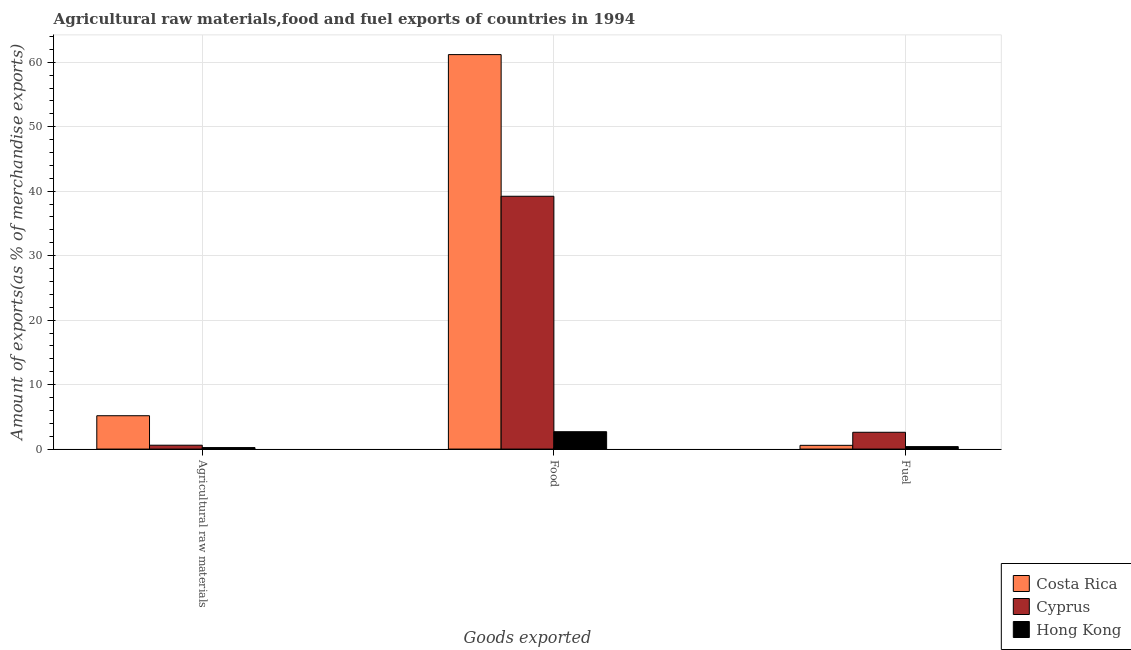How many different coloured bars are there?
Provide a succinct answer. 3. How many groups of bars are there?
Give a very brief answer. 3. What is the label of the 3rd group of bars from the left?
Your response must be concise. Fuel. What is the percentage of fuel exports in Cyprus?
Your answer should be very brief. 2.61. Across all countries, what is the maximum percentage of food exports?
Your answer should be very brief. 61.19. Across all countries, what is the minimum percentage of fuel exports?
Provide a short and direct response. 0.38. In which country was the percentage of food exports maximum?
Ensure brevity in your answer.  Costa Rica. In which country was the percentage of raw materials exports minimum?
Your answer should be very brief. Hong Kong. What is the total percentage of raw materials exports in the graph?
Keep it short and to the point. 6. What is the difference between the percentage of raw materials exports in Hong Kong and that in Cyprus?
Make the answer very short. -0.37. What is the difference between the percentage of raw materials exports in Costa Rica and the percentage of food exports in Hong Kong?
Make the answer very short. 2.48. What is the average percentage of fuel exports per country?
Your answer should be compact. 1.19. What is the difference between the percentage of raw materials exports and percentage of food exports in Hong Kong?
Give a very brief answer. -2.46. In how many countries, is the percentage of fuel exports greater than 40 %?
Provide a succinct answer. 0. What is the ratio of the percentage of raw materials exports in Cyprus to that in Hong Kong?
Your answer should be very brief. 2.57. What is the difference between the highest and the second highest percentage of food exports?
Your answer should be very brief. 21.97. What is the difference between the highest and the lowest percentage of food exports?
Your response must be concise. 58.49. Is the sum of the percentage of fuel exports in Cyprus and Costa Rica greater than the maximum percentage of raw materials exports across all countries?
Offer a terse response. No. What does the 3rd bar from the left in Agricultural raw materials represents?
Keep it short and to the point. Hong Kong. What does the 2nd bar from the right in Agricultural raw materials represents?
Your answer should be very brief. Cyprus. Is it the case that in every country, the sum of the percentage of raw materials exports and percentage of food exports is greater than the percentage of fuel exports?
Keep it short and to the point. Yes. What is the difference between two consecutive major ticks on the Y-axis?
Keep it short and to the point. 10. Are the values on the major ticks of Y-axis written in scientific E-notation?
Offer a terse response. No. Does the graph contain any zero values?
Your answer should be very brief. No. Does the graph contain grids?
Make the answer very short. Yes. What is the title of the graph?
Keep it short and to the point. Agricultural raw materials,food and fuel exports of countries in 1994. Does "Romania" appear as one of the legend labels in the graph?
Your answer should be very brief. No. What is the label or title of the X-axis?
Offer a terse response. Goods exported. What is the label or title of the Y-axis?
Your answer should be very brief. Amount of exports(as % of merchandise exports). What is the Amount of exports(as % of merchandise exports) in Costa Rica in Agricultural raw materials?
Offer a terse response. 5.17. What is the Amount of exports(as % of merchandise exports) in Cyprus in Agricultural raw materials?
Offer a terse response. 0.6. What is the Amount of exports(as % of merchandise exports) in Hong Kong in Agricultural raw materials?
Make the answer very short. 0.23. What is the Amount of exports(as % of merchandise exports) in Costa Rica in Food?
Provide a short and direct response. 61.19. What is the Amount of exports(as % of merchandise exports) in Cyprus in Food?
Provide a succinct answer. 39.21. What is the Amount of exports(as % of merchandise exports) of Hong Kong in Food?
Give a very brief answer. 2.69. What is the Amount of exports(as % of merchandise exports) of Costa Rica in Fuel?
Give a very brief answer. 0.58. What is the Amount of exports(as % of merchandise exports) in Cyprus in Fuel?
Offer a very short reply. 2.61. What is the Amount of exports(as % of merchandise exports) of Hong Kong in Fuel?
Your answer should be compact. 0.38. Across all Goods exported, what is the maximum Amount of exports(as % of merchandise exports) in Costa Rica?
Provide a succinct answer. 61.19. Across all Goods exported, what is the maximum Amount of exports(as % of merchandise exports) in Cyprus?
Your answer should be compact. 39.21. Across all Goods exported, what is the maximum Amount of exports(as % of merchandise exports) in Hong Kong?
Your answer should be compact. 2.69. Across all Goods exported, what is the minimum Amount of exports(as % of merchandise exports) in Costa Rica?
Give a very brief answer. 0.58. Across all Goods exported, what is the minimum Amount of exports(as % of merchandise exports) of Cyprus?
Offer a very short reply. 0.6. Across all Goods exported, what is the minimum Amount of exports(as % of merchandise exports) of Hong Kong?
Your answer should be compact. 0.23. What is the total Amount of exports(as % of merchandise exports) in Costa Rica in the graph?
Your response must be concise. 66.94. What is the total Amount of exports(as % of merchandise exports) in Cyprus in the graph?
Provide a succinct answer. 42.42. What is the total Amount of exports(as % of merchandise exports) in Hong Kong in the graph?
Make the answer very short. 3.31. What is the difference between the Amount of exports(as % of merchandise exports) of Costa Rica in Agricultural raw materials and that in Food?
Your answer should be compact. -56.01. What is the difference between the Amount of exports(as % of merchandise exports) of Cyprus in Agricultural raw materials and that in Food?
Offer a terse response. -38.62. What is the difference between the Amount of exports(as % of merchandise exports) in Hong Kong in Agricultural raw materials and that in Food?
Your answer should be very brief. -2.46. What is the difference between the Amount of exports(as % of merchandise exports) in Costa Rica in Agricultural raw materials and that in Fuel?
Offer a very short reply. 4.59. What is the difference between the Amount of exports(as % of merchandise exports) of Cyprus in Agricultural raw materials and that in Fuel?
Your answer should be compact. -2.01. What is the difference between the Amount of exports(as % of merchandise exports) in Hong Kong in Agricultural raw materials and that in Fuel?
Your response must be concise. -0.15. What is the difference between the Amount of exports(as % of merchandise exports) in Costa Rica in Food and that in Fuel?
Make the answer very short. 60.6. What is the difference between the Amount of exports(as % of merchandise exports) in Cyprus in Food and that in Fuel?
Give a very brief answer. 36.61. What is the difference between the Amount of exports(as % of merchandise exports) in Hong Kong in Food and that in Fuel?
Offer a terse response. 2.31. What is the difference between the Amount of exports(as % of merchandise exports) in Costa Rica in Agricultural raw materials and the Amount of exports(as % of merchandise exports) in Cyprus in Food?
Offer a terse response. -34.04. What is the difference between the Amount of exports(as % of merchandise exports) in Costa Rica in Agricultural raw materials and the Amount of exports(as % of merchandise exports) in Hong Kong in Food?
Ensure brevity in your answer.  2.48. What is the difference between the Amount of exports(as % of merchandise exports) of Cyprus in Agricultural raw materials and the Amount of exports(as % of merchandise exports) of Hong Kong in Food?
Your answer should be compact. -2.09. What is the difference between the Amount of exports(as % of merchandise exports) in Costa Rica in Agricultural raw materials and the Amount of exports(as % of merchandise exports) in Cyprus in Fuel?
Offer a terse response. 2.57. What is the difference between the Amount of exports(as % of merchandise exports) in Costa Rica in Agricultural raw materials and the Amount of exports(as % of merchandise exports) in Hong Kong in Fuel?
Keep it short and to the point. 4.79. What is the difference between the Amount of exports(as % of merchandise exports) of Cyprus in Agricultural raw materials and the Amount of exports(as % of merchandise exports) of Hong Kong in Fuel?
Your response must be concise. 0.22. What is the difference between the Amount of exports(as % of merchandise exports) of Costa Rica in Food and the Amount of exports(as % of merchandise exports) of Cyprus in Fuel?
Give a very brief answer. 58.58. What is the difference between the Amount of exports(as % of merchandise exports) in Costa Rica in Food and the Amount of exports(as % of merchandise exports) in Hong Kong in Fuel?
Give a very brief answer. 60.8. What is the difference between the Amount of exports(as % of merchandise exports) of Cyprus in Food and the Amount of exports(as % of merchandise exports) of Hong Kong in Fuel?
Provide a succinct answer. 38.83. What is the average Amount of exports(as % of merchandise exports) of Costa Rica per Goods exported?
Make the answer very short. 22.31. What is the average Amount of exports(as % of merchandise exports) in Cyprus per Goods exported?
Provide a short and direct response. 14.14. What is the average Amount of exports(as % of merchandise exports) in Hong Kong per Goods exported?
Offer a very short reply. 1.1. What is the difference between the Amount of exports(as % of merchandise exports) in Costa Rica and Amount of exports(as % of merchandise exports) in Cyprus in Agricultural raw materials?
Keep it short and to the point. 4.57. What is the difference between the Amount of exports(as % of merchandise exports) of Costa Rica and Amount of exports(as % of merchandise exports) of Hong Kong in Agricultural raw materials?
Your answer should be compact. 4.94. What is the difference between the Amount of exports(as % of merchandise exports) of Cyprus and Amount of exports(as % of merchandise exports) of Hong Kong in Agricultural raw materials?
Keep it short and to the point. 0.37. What is the difference between the Amount of exports(as % of merchandise exports) of Costa Rica and Amount of exports(as % of merchandise exports) of Cyprus in Food?
Offer a terse response. 21.97. What is the difference between the Amount of exports(as % of merchandise exports) of Costa Rica and Amount of exports(as % of merchandise exports) of Hong Kong in Food?
Give a very brief answer. 58.49. What is the difference between the Amount of exports(as % of merchandise exports) in Cyprus and Amount of exports(as % of merchandise exports) in Hong Kong in Food?
Keep it short and to the point. 36.52. What is the difference between the Amount of exports(as % of merchandise exports) in Costa Rica and Amount of exports(as % of merchandise exports) in Cyprus in Fuel?
Offer a very short reply. -2.03. What is the difference between the Amount of exports(as % of merchandise exports) of Costa Rica and Amount of exports(as % of merchandise exports) of Hong Kong in Fuel?
Give a very brief answer. 0.2. What is the difference between the Amount of exports(as % of merchandise exports) of Cyprus and Amount of exports(as % of merchandise exports) of Hong Kong in Fuel?
Your answer should be compact. 2.22. What is the ratio of the Amount of exports(as % of merchandise exports) in Costa Rica in Agricultural raw materials to that in Food?
Offer a terse response. 0.08. What is the ratio of the Amount of exports(as % of merchandise exports) of Cyprus in Agricultural raw materials to that in Food?
Give a very brief answer. 0.02. What is the ratio of the Amount of exports(as % of merchandise exports) in Hong Kong in Agricultural raw materials to that in Food?
Provide a short and direct response. 0.09. What is the ratio of the Amount of exports(as % of merchandise exports) in Costa Rica in Agricultural raw materials to that in Fuel?
Offer a terse response. 8.91. What is the ratio of the Amount of exports(as % of merchandise exports) in Cyprus in Agricultural raw materials to that in Fuel?
Offer a terse response. 0.23. What is the ratio of the Amount of exports(as % of merchandise exports) of Hong Kong in Agricultural raw materials to that in Fuel?
Ensure brevity in your answer.  0.61. What is the ratio of the Amount of exports(as % of merchandise exports) of Costa Rica in Food to that in Fuel?
Provide a short and direct response. 105.37. What is the ratio of the Amount of exports(as % of merchandise exports) of Cyprus in Food to that in Fuel?
Keep it short and to the point. 15.04. What is the ratio of the Amount of exports(as % of merchandise exports) of Hong Kong in Food to that in Fuel?
Provide a succinct answer. 7.04. What is the difference between the highest and the second highest Amount of exports(as % of merchandise exports) of Costa Rica?
Provide a short and direct response. 56.01. What is the difference between the highest and the second highest Amount of exports(as % of merchandise exports) of Cyprus?
Provide a short and direct response. 36.61. What is the difference between the highest and the second highest Amount of exports(as % of merchandise exports) of Hong Kong?
Your answer should be compact. 2.31. What is the difference between the highest and the lowest Amount of exports(as % of merchandise exports) in Costa Rica?
Give a very brief answer. 60.6. What is the difference between the highest and the lowest Amount of exports(as % of merchandise exports) of Cyprus?
Make the answer very short. 38.62. What is the difference between the highest and the lowest Amount of exports(as % of merchandise exports) of Hong Kong?
Your answer should be very brief. 2.46. 